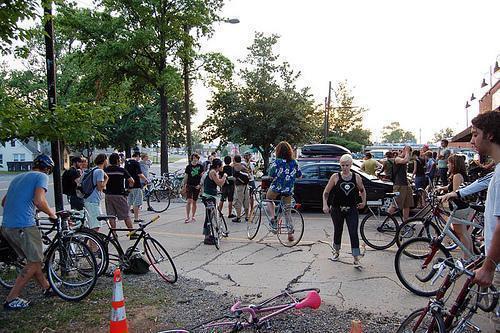Where would you normally find the orange and white thing in the foreground?
Answer the question by selecting the correct answer among the 4 following choices and explain your choice with a short sentence. The answer should be formatted with the following format: `Answer: choice
Rationale: rationale.`
Options: Playground, pub, beach, road. Answer: road.
Rationale: The object in the foreground is a traffic or warning cone. these are often placed in roads to advise people of hazards or direct them away from certain places. 